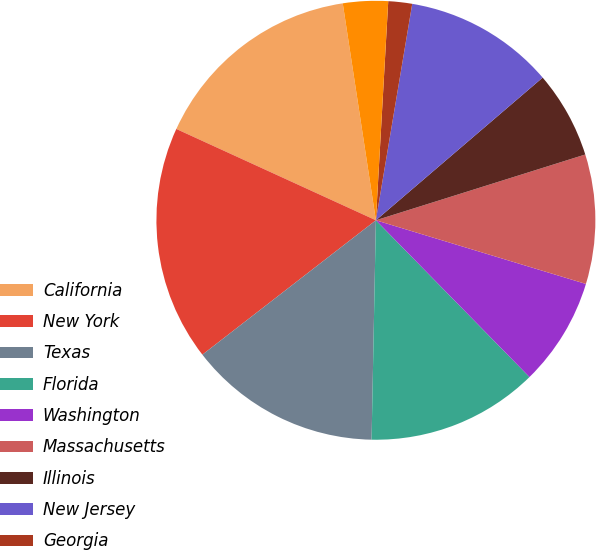Convert chart. <chart><loc_0><loc_0><loc_500><loc_500><pie_chart><fcel>California<fcel>New York<fcel>Texas<fcel>Florida<fcel>Washington<fcel>Massachusetts<fcel>Illinois<fcel>New Jersey<fcel>Georgia<fcel>Ohio<nl><fcel>15.76%<fcel>17.32%<fcel>14.2%<fcel>12.65%<fcel>7.98%<fcel>9.53%<fcel>6.42%<fcel>11.09%<fcel>1.75%<fcel>3.31%<nl></chart> 